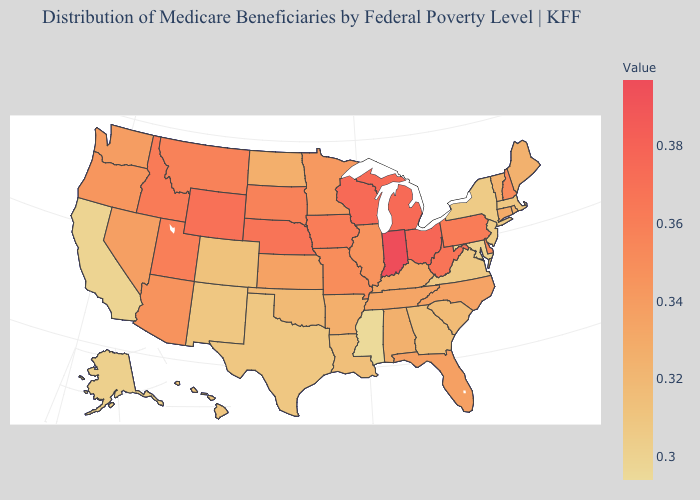Does Wyoming have a lower value than Texas?
Keep it brief. No. Does North Dakota have the lowest value in the MidWest?
Quick response, please. Yes. Among the states that border Utah , does Wyoming have the highest value?
Be succinct. Yes. Which states have the lowest value in the West?
Give a very brief answer. California. Does the map have missing data?
Write a very short answer. No. Among the states that border Vermont , which have the lowest value?
Keep it brief. New York. Does Colorado have the highest value in the USA?
Answer briefly. No. 